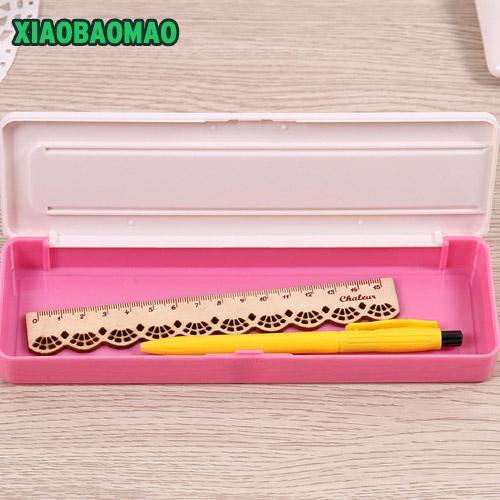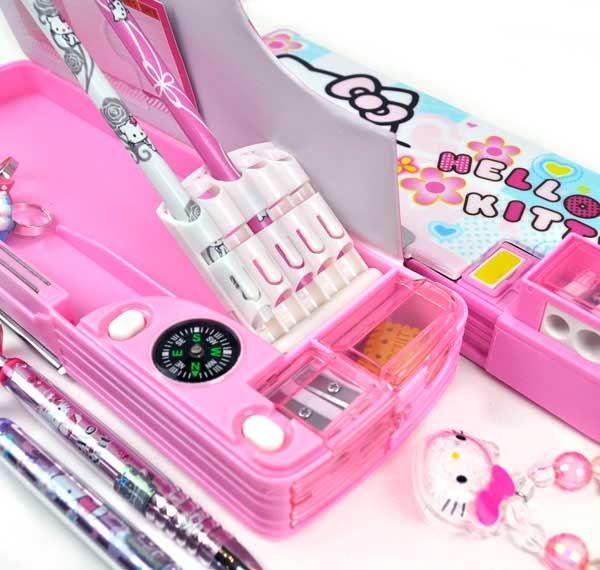The first image is the image on the left, the second image is the image on the right. Given the left and right images, does the statement "Right image shows a pencil case decorated on top with a variety of cute animals, including a rabbit, dog, cat and bear." hold true? Answer yes or no. No. The first image is the image on the left, the second image is the image on the right. For the images displayed, is the sentence "There are exactly two hard plastic pencil boxes that are both closed." factually correct? Answer yes or no. No. 